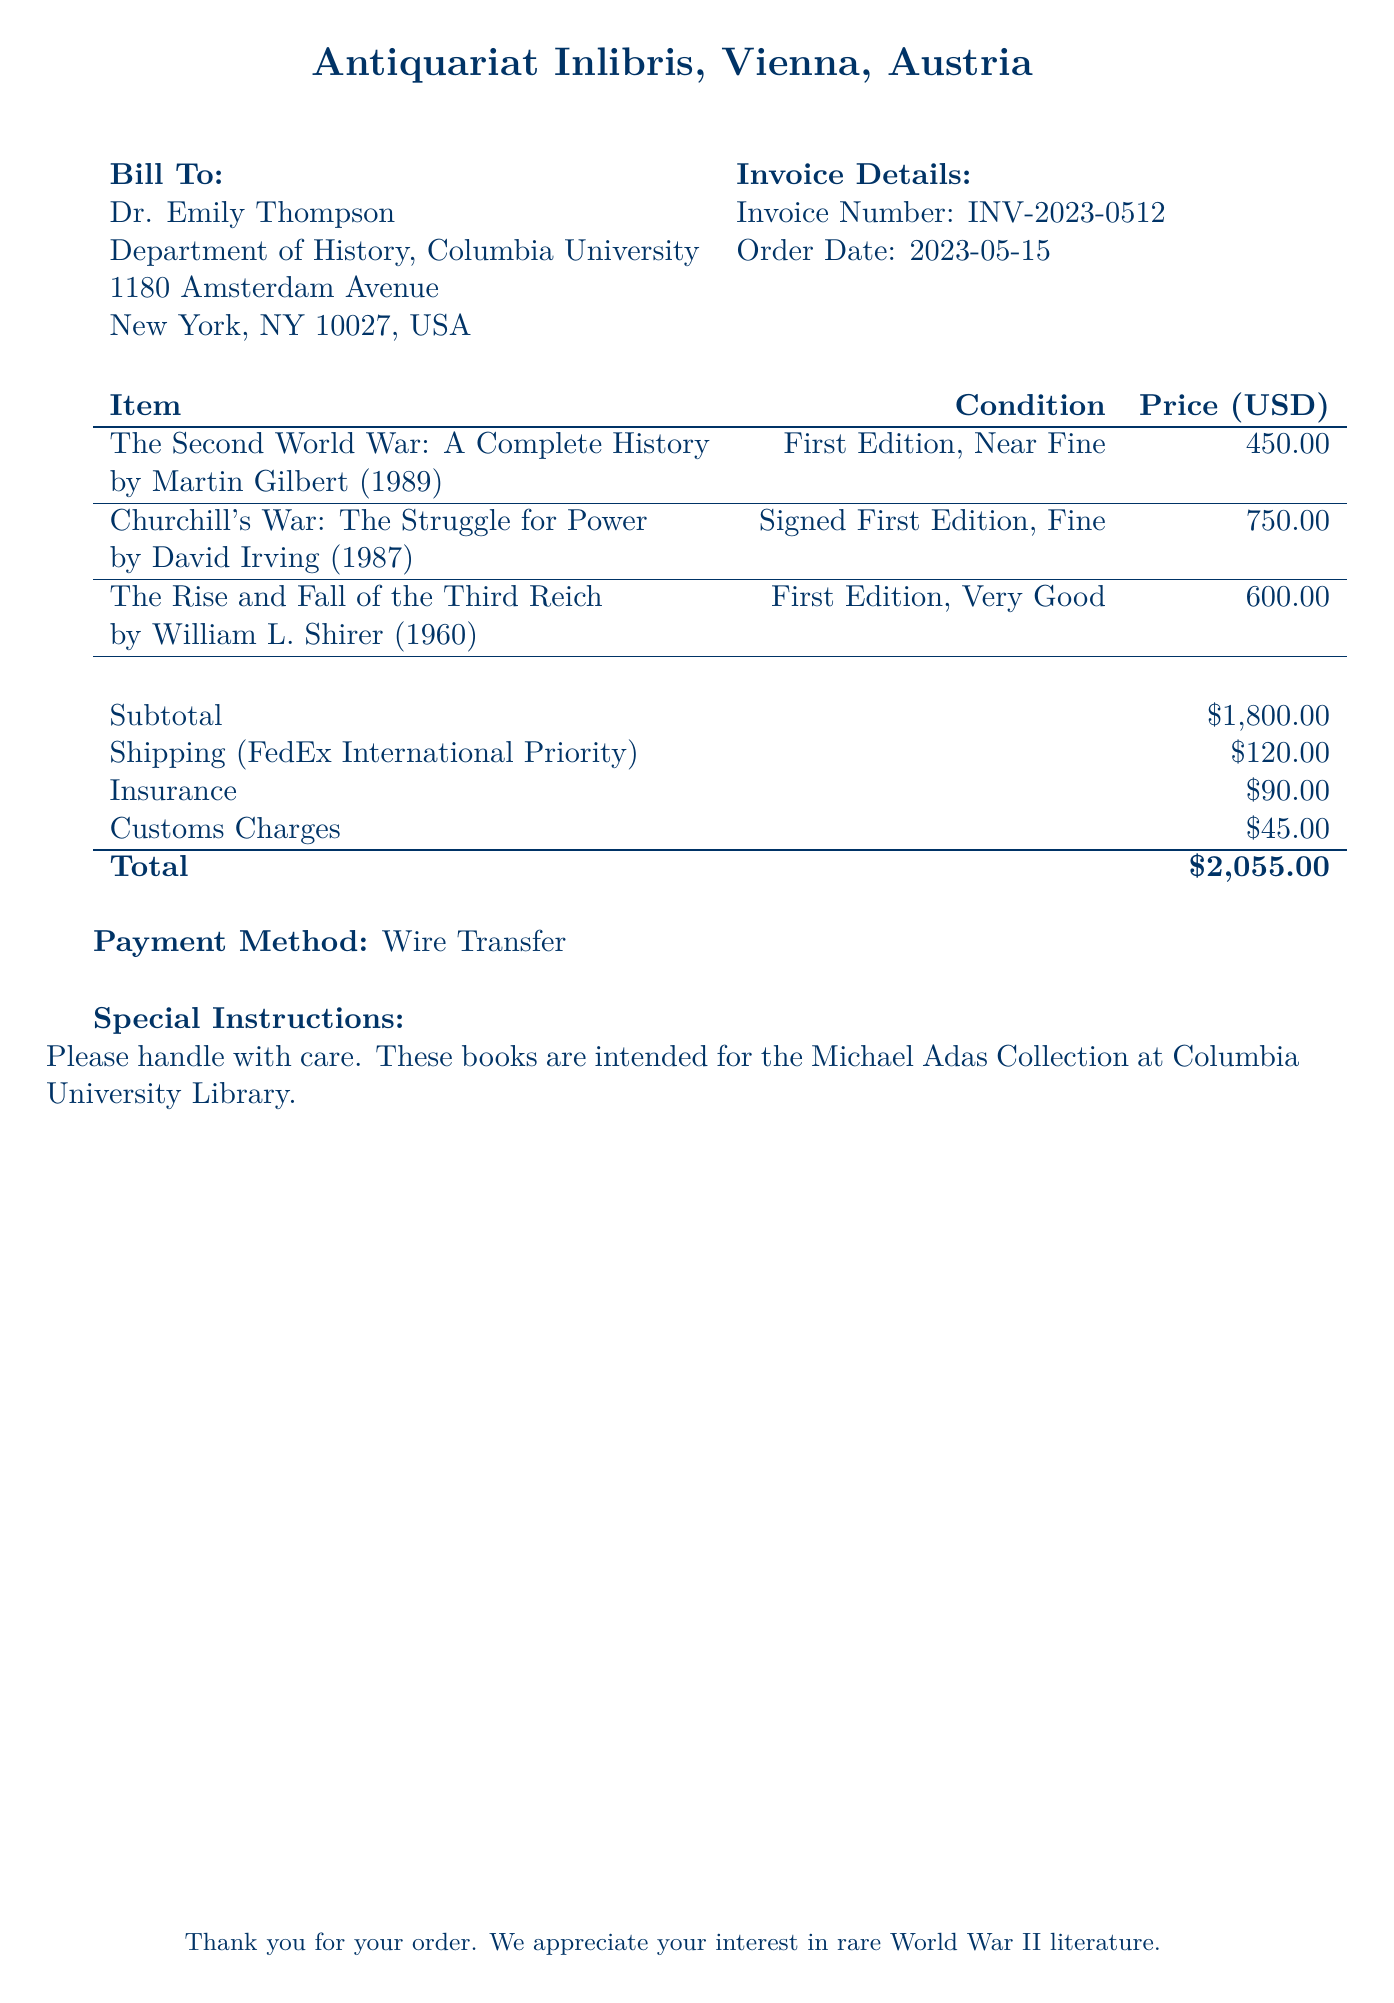what is the invoice number? The invoice number is listed at the top of the invoice details section, which is INV-2023-0512.
Answer: INV-2023-0512 who is the bill addressed to? The bill is addressed to Dr. Emily Thompson, as indicated in the "Bill To" section.
Answer: Dr. Emily Thompson what is the total price of the books? The total price is listed at the bottom of the invoice, which sums all costs, resulting in $2,055.00.
Answer: $2,055.00 which shipping method is used? The shipping method is noted as FedEx International Priority in the billing details.
Answer: FedEx International Priority how much is charged for customs? The customs charges are specified in the billing details, listed as $45.00.
Answer: $45.00 what is the condition of "The Second World War: A Complete History"? The condition of this book is described in the item listing as "First Edition, Near Fine."
Answer: First Edition, Near Fine what is the subtotal for the books before additional charges? The subtotal is provided right above the shipping costs and is $1,800.00.
Answer: $1,800.00 what is the special instruction noted in the bill? The special instruction requests careful handling, as these books are for the Michael Adas Collection.
Answer: Please handle with care. These books are intended for the Michael Adas Collection at Columbia University Library 